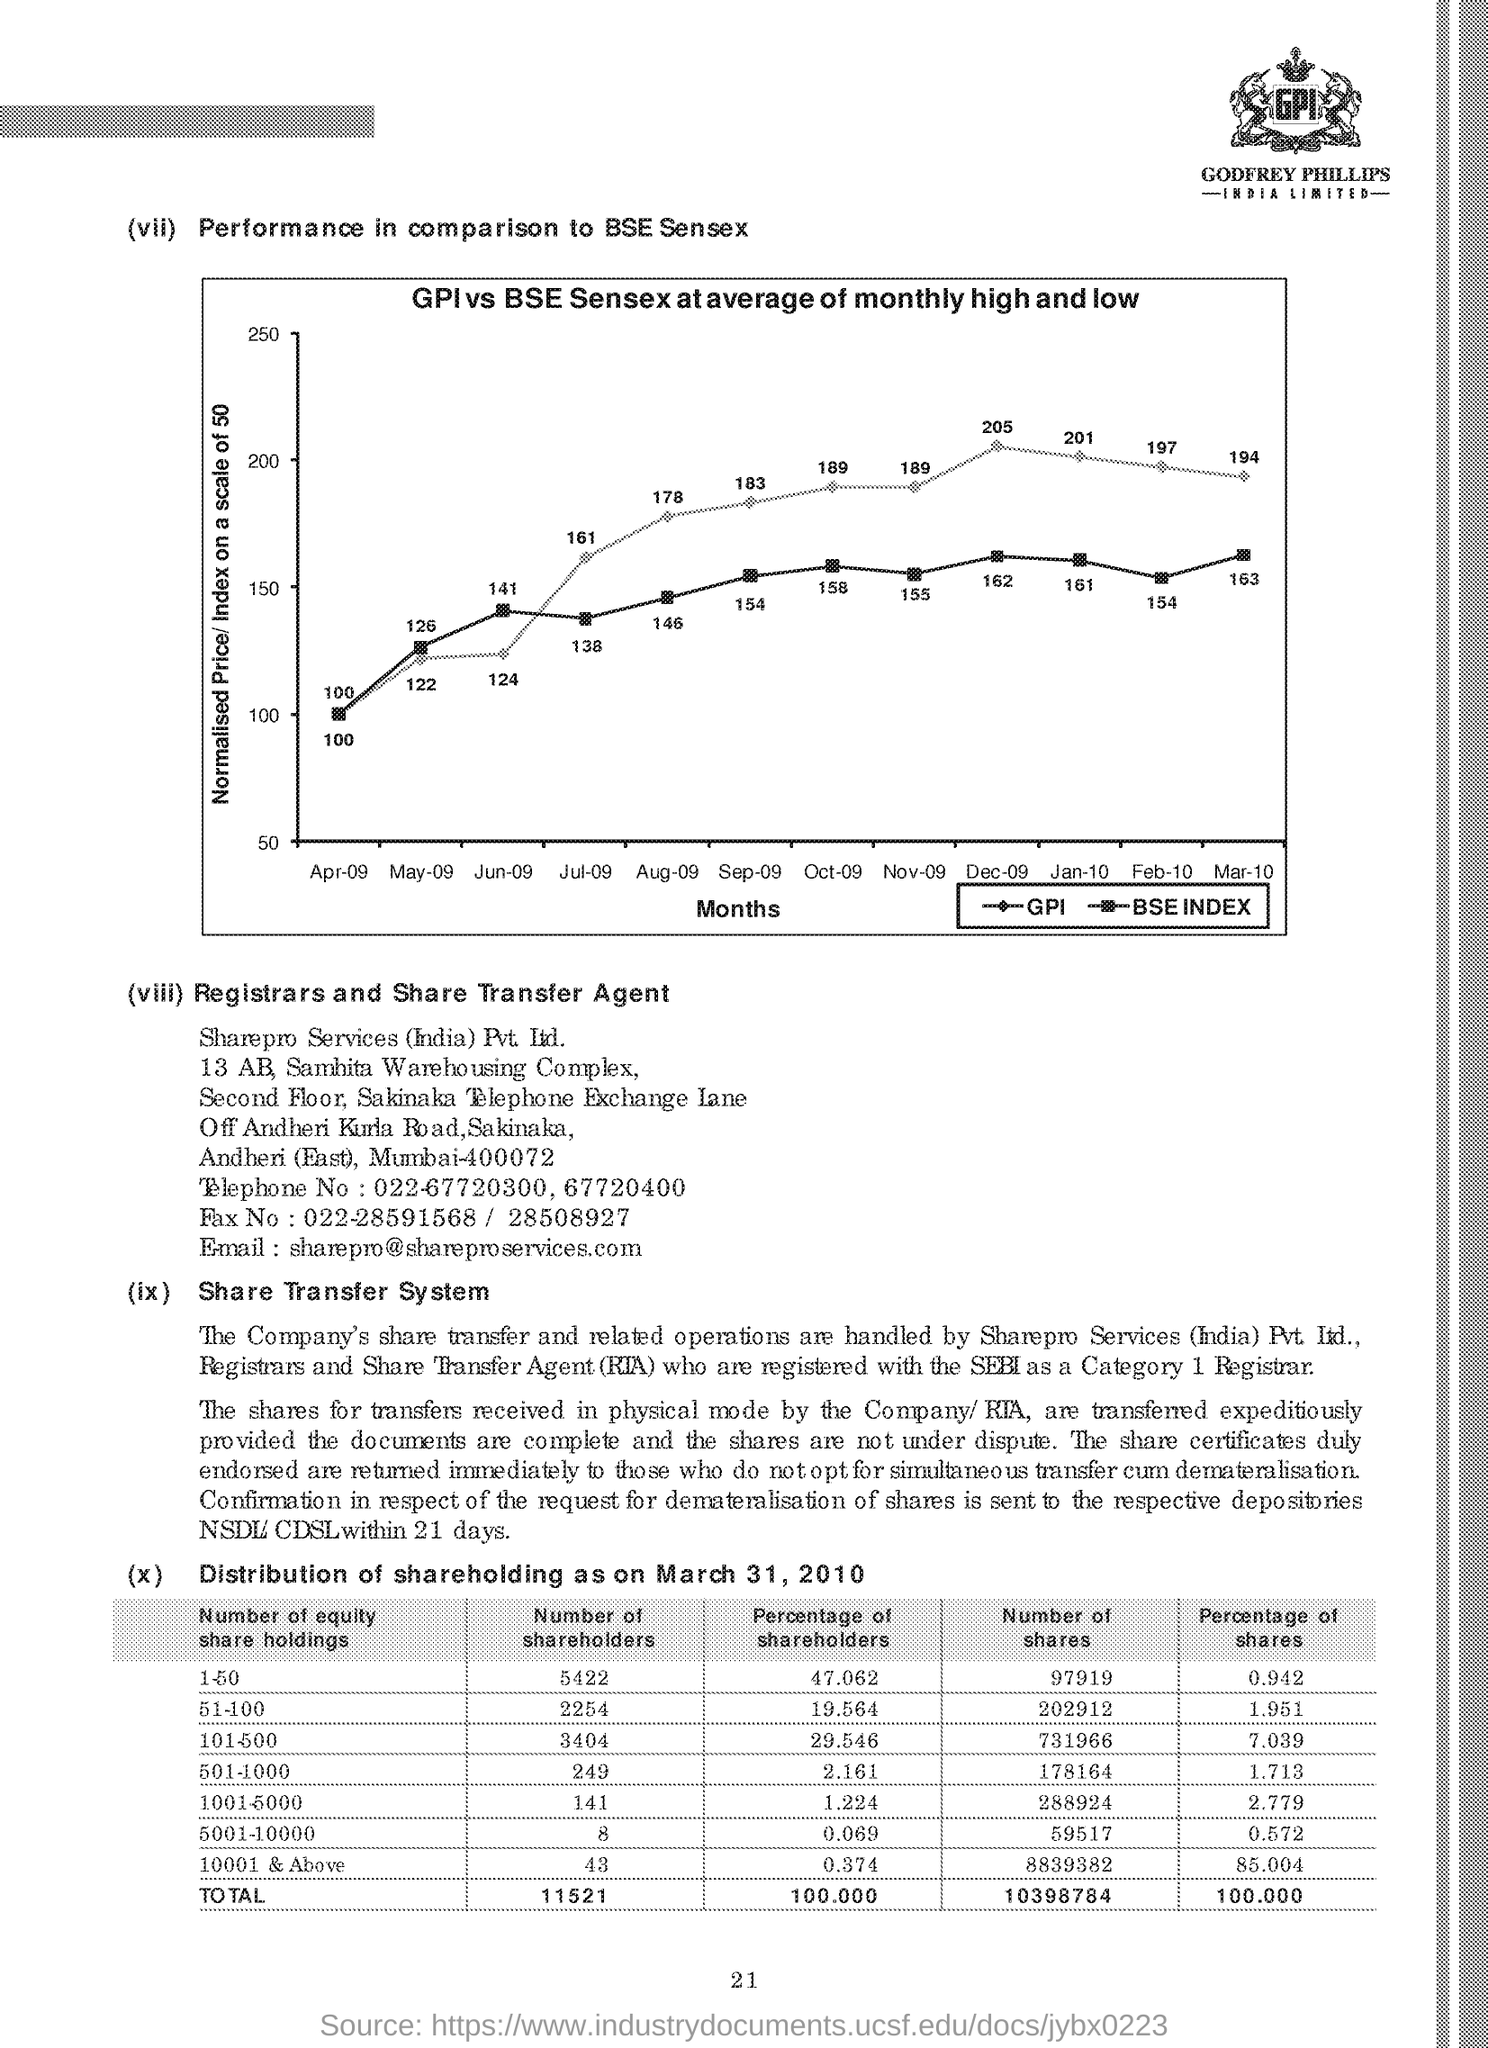Outline some significant characteristics in this image. The performance price of GPI Sensex in the month of April was 100. The normalized price scale ranges from 0 to 100. The performance price of the BSESensex in the month of July was 138. 